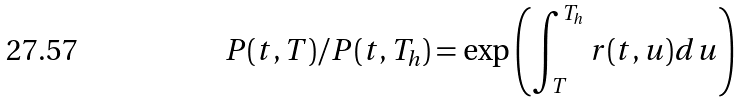<formula> <loc_0><loc_0><loc_500><loc_500>P ( t , T ) / P ( t , T _ { h } ) = \exp \left ( \int _ { T } ^ { T _ { h } } r ( t , u ) d u \right )</formula> 